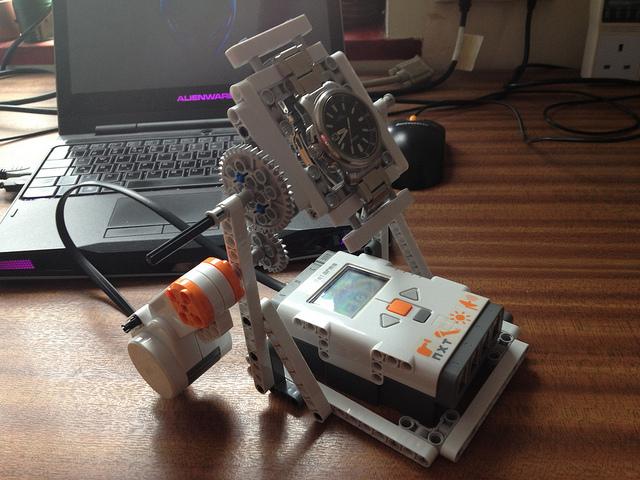What kind of electronic device is this?
Be succinct. Watch. Is that a watch on the device?
Be succinct. Yes. Is this on a floor?
Keep it brief. Yes. 